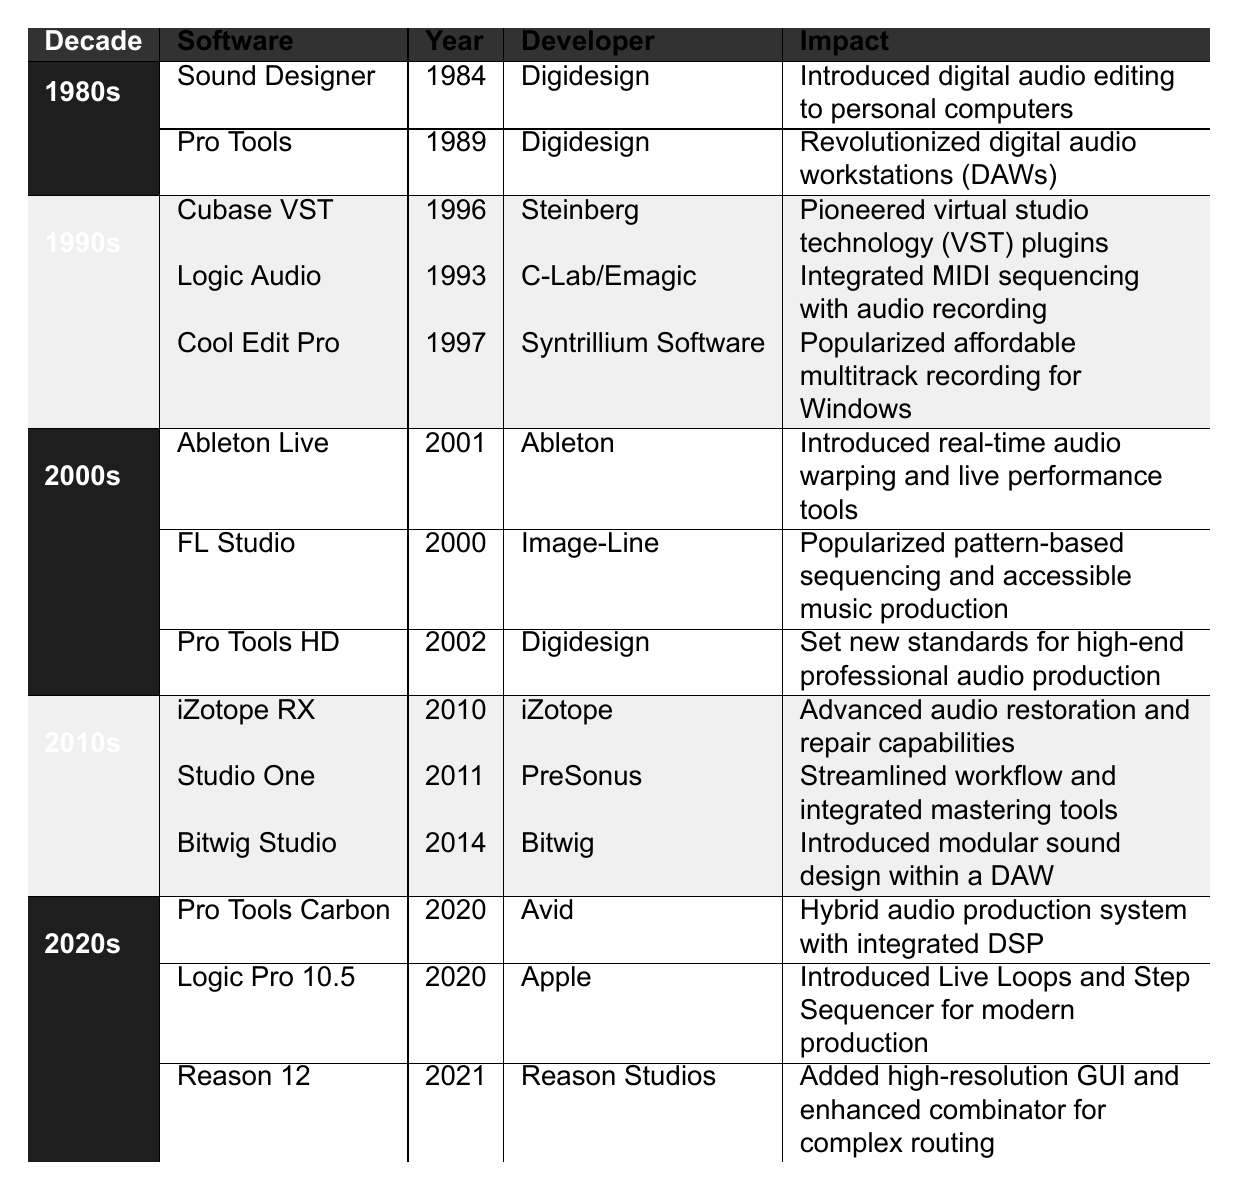What software was released by Digidesign in the 1980s? According to the table, Digidesign released two software products in the 1980s: Sound Designer in 1984 and Pro Tools in 1989.
Answer: Sound Designer and Pro Tools Which decade saw the release of Logic Audio? The table lists Logic Audio as released in 1993, which is in the 1990s decade.
Answer: 1990s What is the impact of Ableton Live? The table states that Ableton Live introduced real-time audio warping and live performance tools which significantly impacted production techniques.
Answer: Introduced real-time audio warping and live performance tools Is FL Studio associated with image-line? The table shows that FL Studio was developed by Image-Line, indicating a true connection.
Answer: Yes Which two software releases occurred in the same year, 2020? In the table, both Pro Tools Carbon and Logic Pro 10.5 are listed with the release year of 2020.
Answer: Pro Tools Carbon and Logic Pro 10.5 Count the total number of software releases in the 2000s. From the table, three software releases are in the 2000s: Ableton Live, FL Studio, and Pro Tools HD, which sums up to three.
Answer: 3 What was the primary impact of Cubase VST? The impact listed for Cubase VST in the table is that it pioneered virtual studio technology (VST) plugins, which was a significant advancement in music production.
Answer: Pioneered virtual studio technology (VST) plugins How many software releases mentioned had an impact related to audio restoration? The table indicates that only one software, iZotope RX (released in 2010), had an impact related to audio restoration.
Answer: 1 Which decade included the most software releases in the table? By reviewing the entries, the 1990s include three releases, while other decades have fewer (1980s and 2000s have two each, and 2010s and 2020s have three), but 1990s has a distinctly higher profile.
Answer: 1990s What features were introduced with Logic Pro 10.5? The table notes that Logic Pro 10.5 introduced Live Loops and Step Sequencer, marking a significant update in modern production tools.
Answer: Live Loops and Step Sequencer 